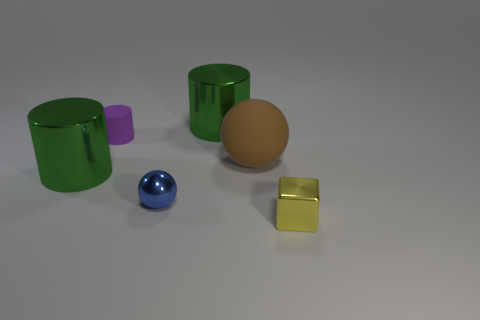Is there a small cube made of the same material as the yellow object?
Provide a short and direct response. No. Is the small blue ball made of the same material as the big ball?
Keep it short and to the point. No. What number of red objects are either tiny rubber cylinders or tiny cubes?
Your response must be concise. 0. Is the number of big metal cylinders in front of the tiny yellow object greater than the number of brown rubber spheres?
Provide a short and direct response. No. Is there a big metal thing of the same color as the tiny cube?
Keep it short and to the point. No. What size is the blue sphere?
Your answer should be compact. Small. Is the big matte ball the same color as the cube?
Your answer should be compact. No. What number of things are either tiny matte things or large green shiny things that are left of the blue object?
Keep it short and to the point. 2. Is the number of purple metal things the same as the number of small blue metal spheres?
Make the answer very short. No. There is a metal object in front of the tiny metal thing that is behind the tiny yellow metallic thing; what number of metallic cubes are left of it?
Ensure brevity in your answer.  0. 